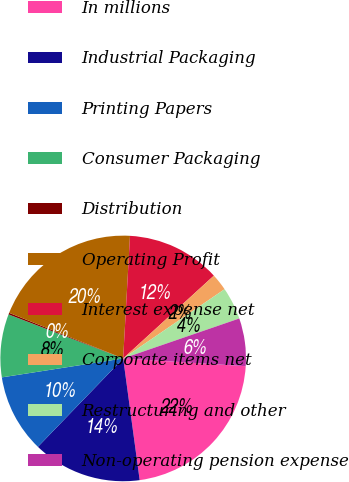Convert chart. <chart><loc_0><loc_0><loc_500><loc_500><pie_chart><fcel>In millions<fcel>Industrial Packaging<fcel>Printing Papers<fcel>Consumer Packaging<fcel>Distribution<fcel>Operating Profit<fcel>Interest expense net<fcel>Corporate items net<fcel>Restructuring and other<fcel>Non-operating pension expense<nl><fcel>21.85%<fcel>14.36%<fcel>10.32%<fcel>8.3%<fcel>0.22%<fcel>19.83%<fcel>12.34%<fcel>2.24%<fcel>4.26%<fcel>6.28%<nl></chart> 